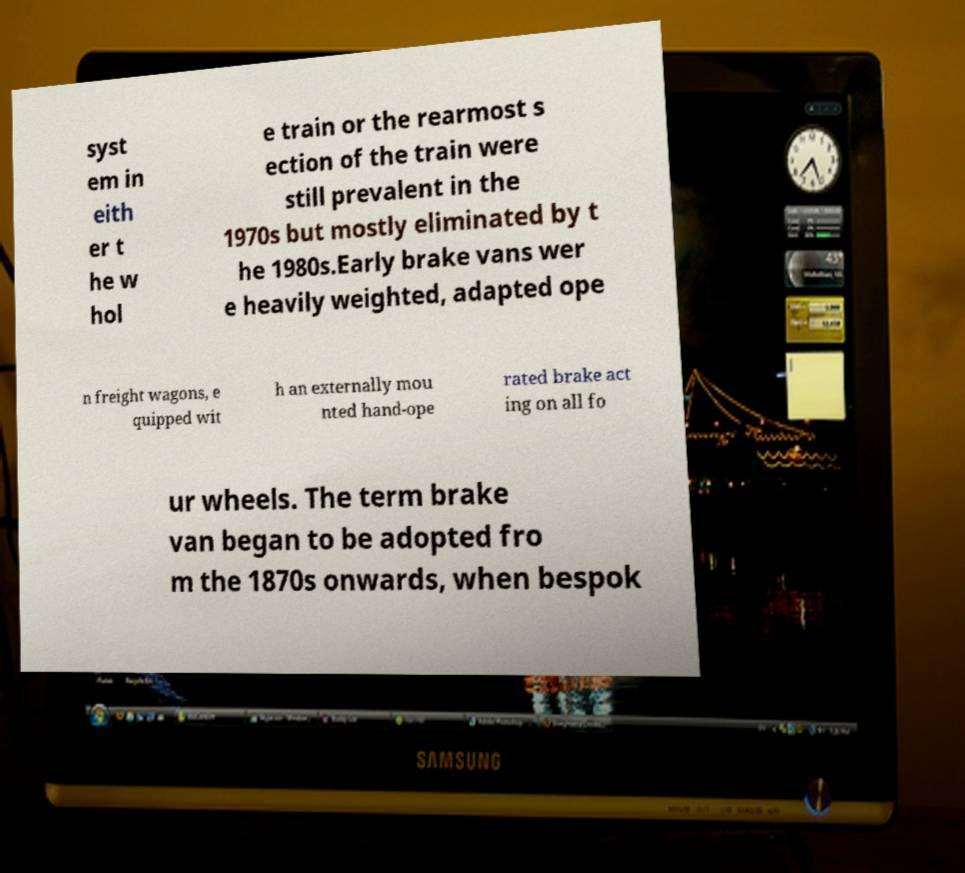Can you accurately transcribe the text from the provided image for me? syst em in eith er t he w hol e train or the rearmost s ection of the train were still prevalent in the 1970s but mostly eliminated by t he 1980s.Early brake vans wer e heavily weighted, adapted ope n freight wagons, e quipped wit h an externally mou nted hand-ope rated brake act ing on all fo ur wheels. The term brake van began to be adopted fro m the 1870s onwards, when bespok 